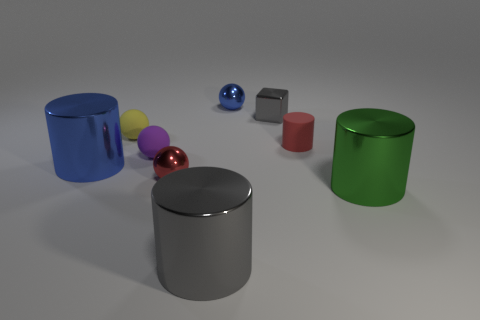Subtract all purple cylinders. Subtract all gray balls. How many cylinders are left? 4 Subtract all spheres. How many objects are left? 5 Add 2 big gray things. How many big gray things are left? 3 Add 5 large green metal cylinders. How many large green metal cylinders exist? 6 Subtract 0 green spheres. How many objects are left? 9 Subtract all small red metallic things. Subtract all small matte cylinders. How many objects are left? 7 